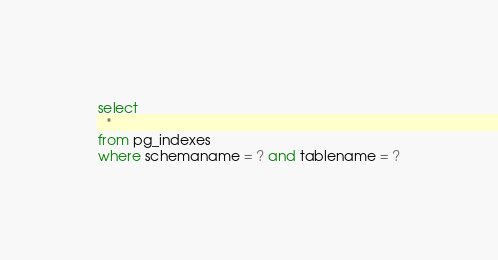<code> <loc_0><loc_0><loc_500><loc_500><_SQL_>select
  *
from pg_indexes
where schemaname = ? and tablename = ?</code> 